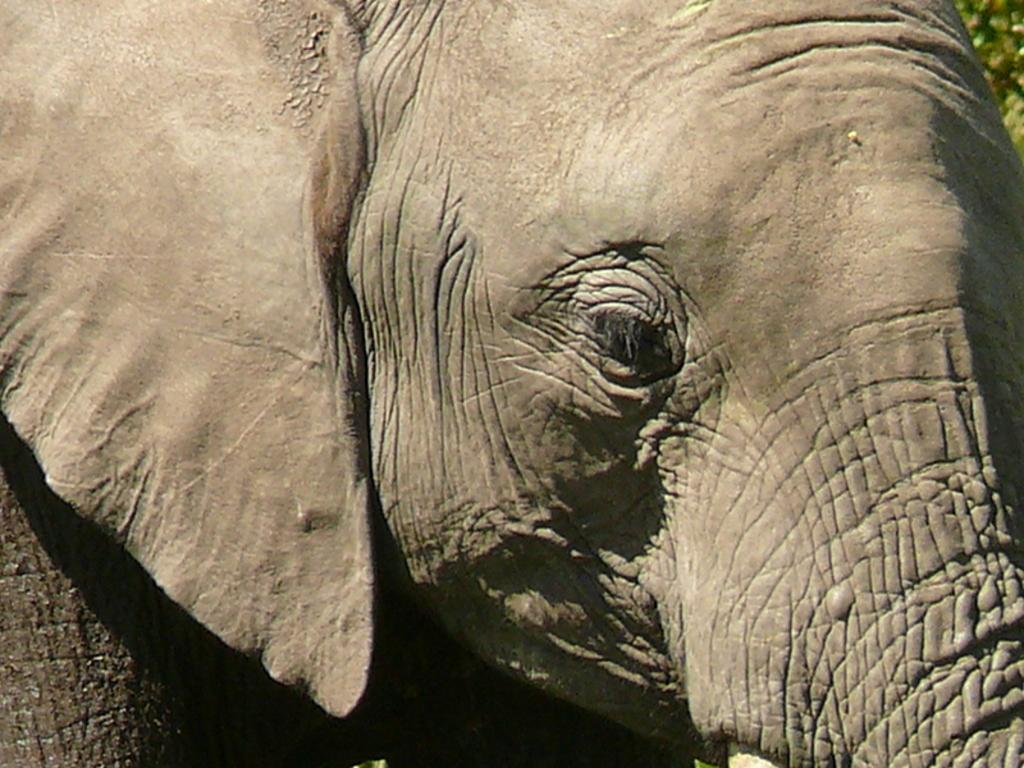What type of animal is the main subject of the image? There is an elephant in the image. What type of collar is the elephant wearing in the image? There is no collar present on the elephant in the image. What way does the elephant travel in the image? The image does not show the elephant traveling, so it cannot be determined from the image. 